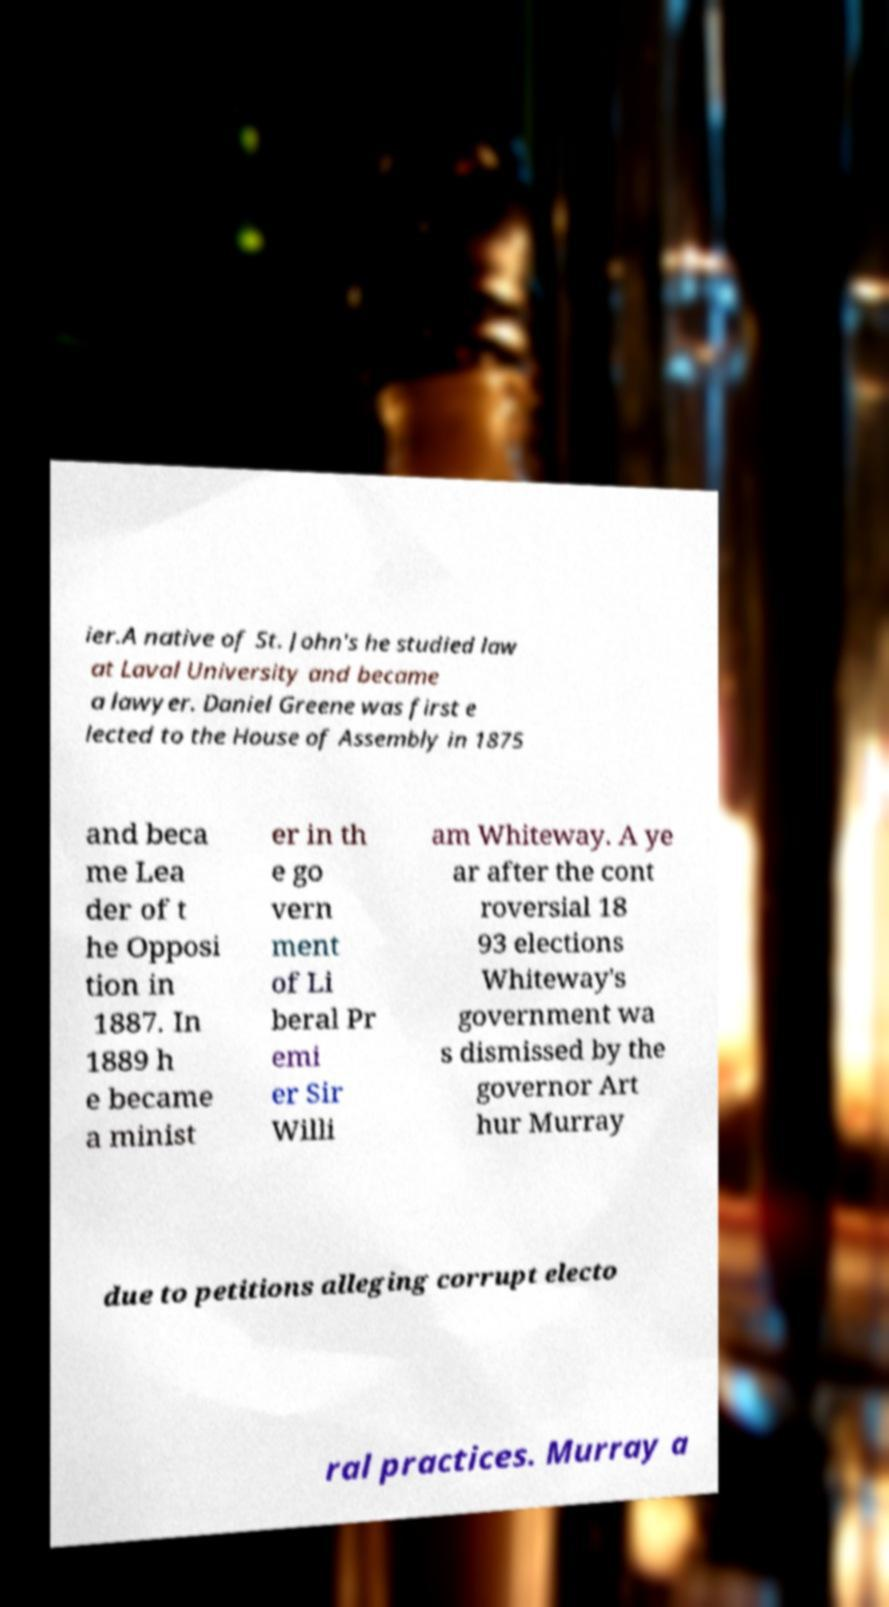For documentation purposes, I need the text within this image transcribed. Could you provide that? ier.A native of St. John's he studied law at Laval University and became a lawyer. Daniel Greene was first e lected to the House of Assembly in 1875 and beca me Lea der of t he Opposi tion in 1887. In 1889 h e became a minist er in th e go vern ment of Li beral Pr emi er Sir Willi am Whiteway. A ye ar after the cont roversial 18 93 elections Whiteway's government wa s dismissed by the governor Art hur Murray due to petitions alleging corrupt electo ral practices. Murray a 